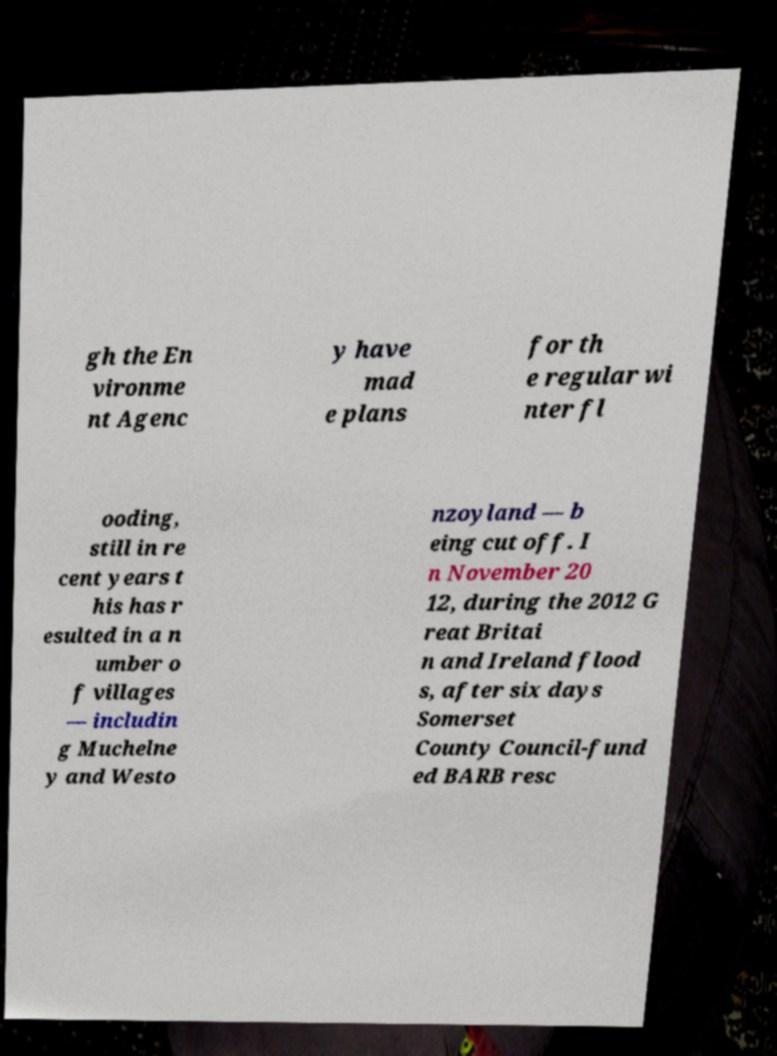For documentation purposes, I need the text within this image transcribed. Could you provide that? gh the En vironme nt Agenc y have mad e plans for th e regular wi nter fl ooding, still in re cent years t his has r esulted in a n umber o f villages — includin g Muchelne y and Westo nzoyland — b eing cut off. I n November 20 12, during the 2012 G reat Britai n and Ireland flood s, after six days Somerset County Council-fund ed BARB resc 